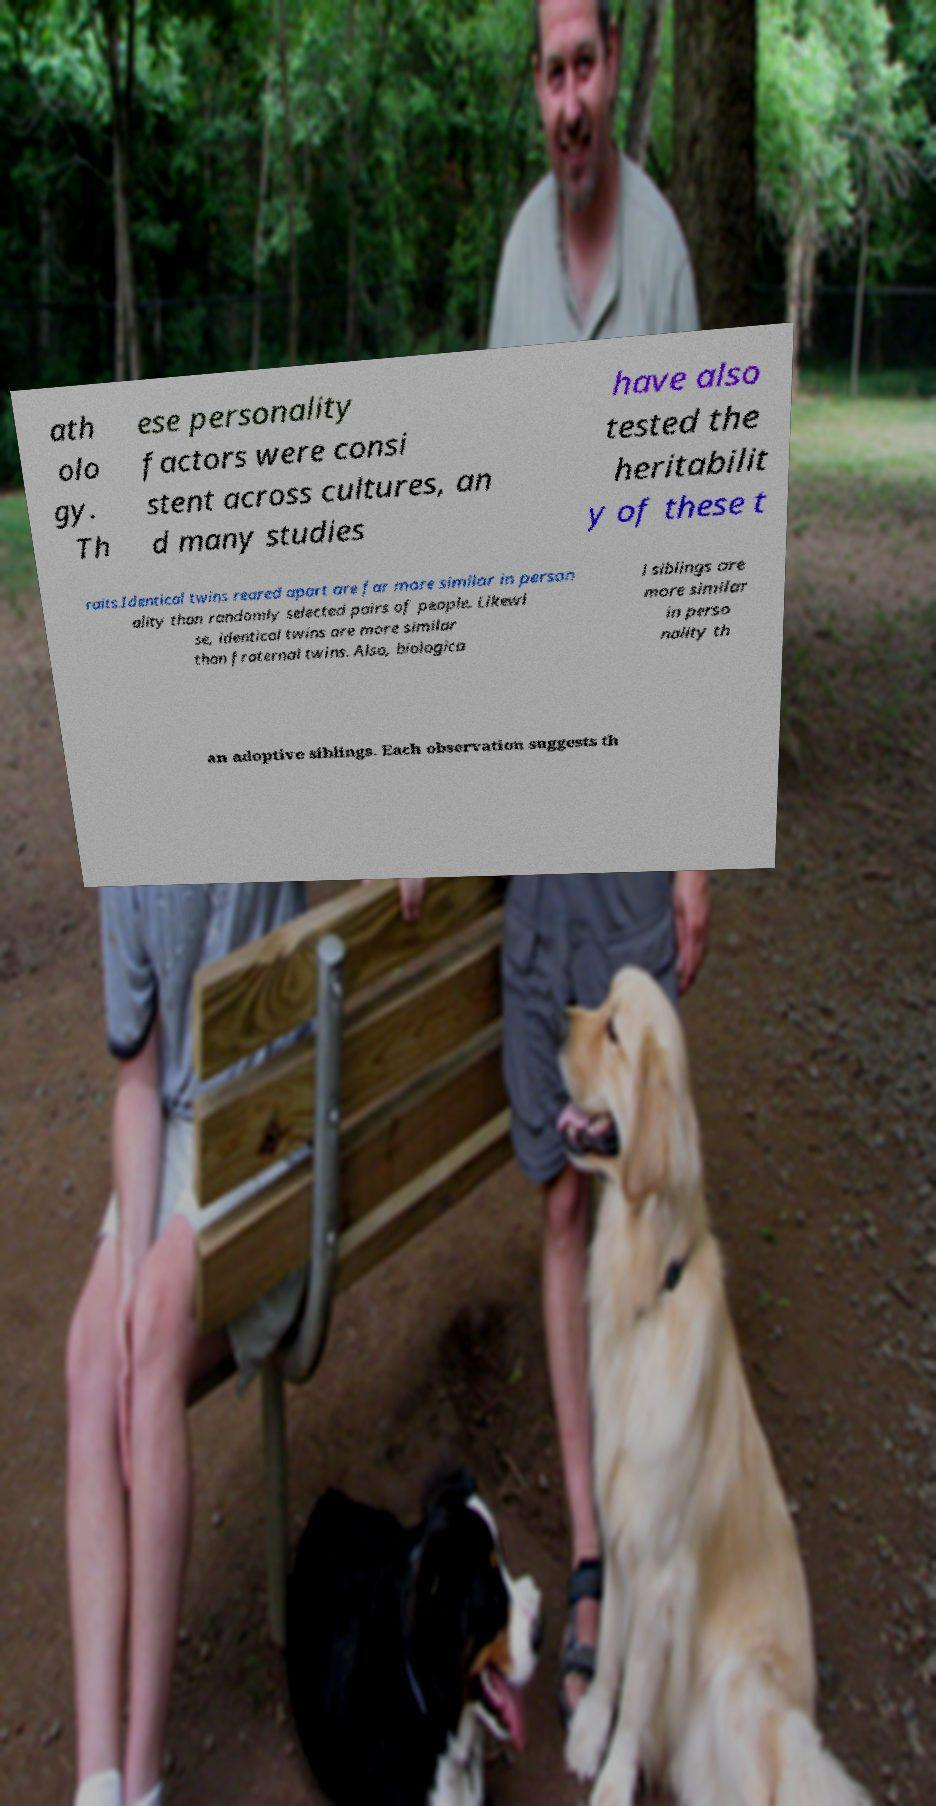Can you read and provide the text displayed in the image?This photo seems to have some interesting text. Can you extract and type it out for me? ath olo gy. Th ese personality factors were consi stent across cultures, an d many studies have also tested the heritabilit y of these t raits.Identical twins reared apart are far more similar in person ality than randomly selected pairs of people. Likewi se, identical twins are more similar than fraternal twins. Also, biologica l siblings are more similar in perso nality th an adoptive siblings. Each observation suggests th 